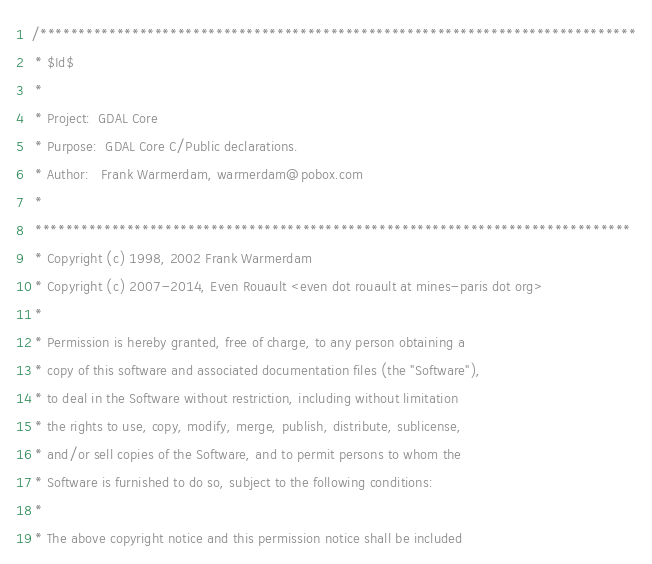Convert code to text. <code><loc_0><loc_0><loc_500><loc_500><_C_>/******************************************************************************
 * $Id$
 *
 * Project:  GDAL Core
 * Purpose:  GDAL Core C/Public declarations.
 * Author:   Frank Warmerdam, warmerdam@pobox.com
 *
 ******************************************************************************
 * Copyright (c) 1998, 2002 Frank Warmerdam
 * Copyright (c) 2007-2014, Even Rouault <even dot rouault at mines-paris dot org>
 *
 * Permission is hereby granted, free of charge, to any person obtaining a
 * copy of this software and associated documentation files (the "Software"),
 * to deal in the Software without restriction, including without limitation
 * the rights to use, copy, modify, merge, publish, distribute, sublicense,
 * and/or sell copies of the Software, and to permit persons to whom the
 * Software is furnished to do so, subject to the following conditions:
 *
 * The above copyright notice and this permission notice shall be included</code> 